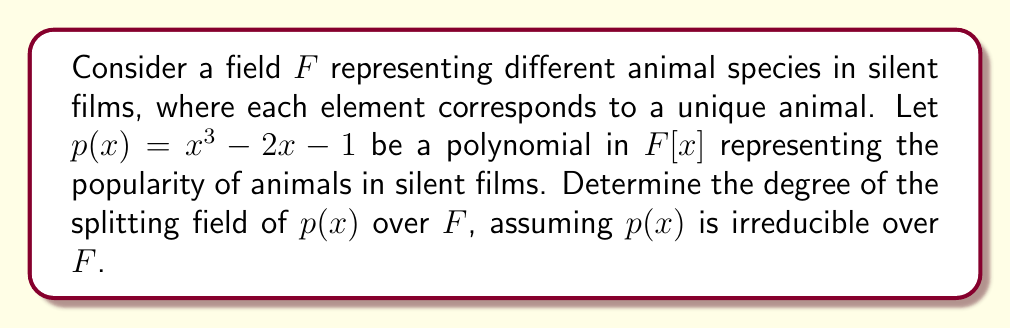Can you answer this question? To solve this problem, we'll follow these steps:

1) First, recall that the splitting field of a polynomial $p(x)$ over a field $F$ is the smallest extension of $F$ that contains all the roots of $p(x)$.

2) Given that $p(x) = x^3 - 2x - 1$ is irreducible over $F$, it has no roots in $F$. Let $\alpha$ be a root of $p(x)$ in some extension of $F$.

3) The degree of the splitting field over $F$ is equal to the product of two factors:
   a) The degree of $F(\alpha)$ over $F$, which is the degree of the minimal polynomial of $\alpha$ over $F$.
   b) The degree of the splitting field of $p(x)$ over $F(\alpha)$.

4) Since $p(x)$ is irreducible and of degree 3, $[F(\alpha):F] = 3$.

5) In $F(\alpha)$, $p(x)$ factors as:
   $$p(x) = (x - \alpha)(x^2 + \alpha x + (\alpha^2 - 2))$$

6) The remaining quadratic factor may or may not be reducible over $F(\alpha)$. If it's reducible, the splitting field is $F(\alpha)$. If it's irreducible, the splitting field is a quadratic extension of $F(\alpha)$.

7) To determine which case we're in, we need to check if the discriminant of the quadratic factor is a square in $F(\alpha)$. The discriminant is:
   $$\Delta = \alpha^2 - 4(\alpha^2 - 2) = -3\alpha^2 + 8$$

8) If $\Delta$ is a square in $F(\alpha)$, then $[K:F(\alpha)] = 1$, where $K$ is the splitting field. If not, $[K:F(\alpha)] = 2$.

9) Without more information about $F$, we can't determine whether $\Delta$ is a square in $F(\alpha)$. Therefore, we conclude that the degree of the splitting field over $F$ is either 3 or 6.
Answer: 3 or 6 